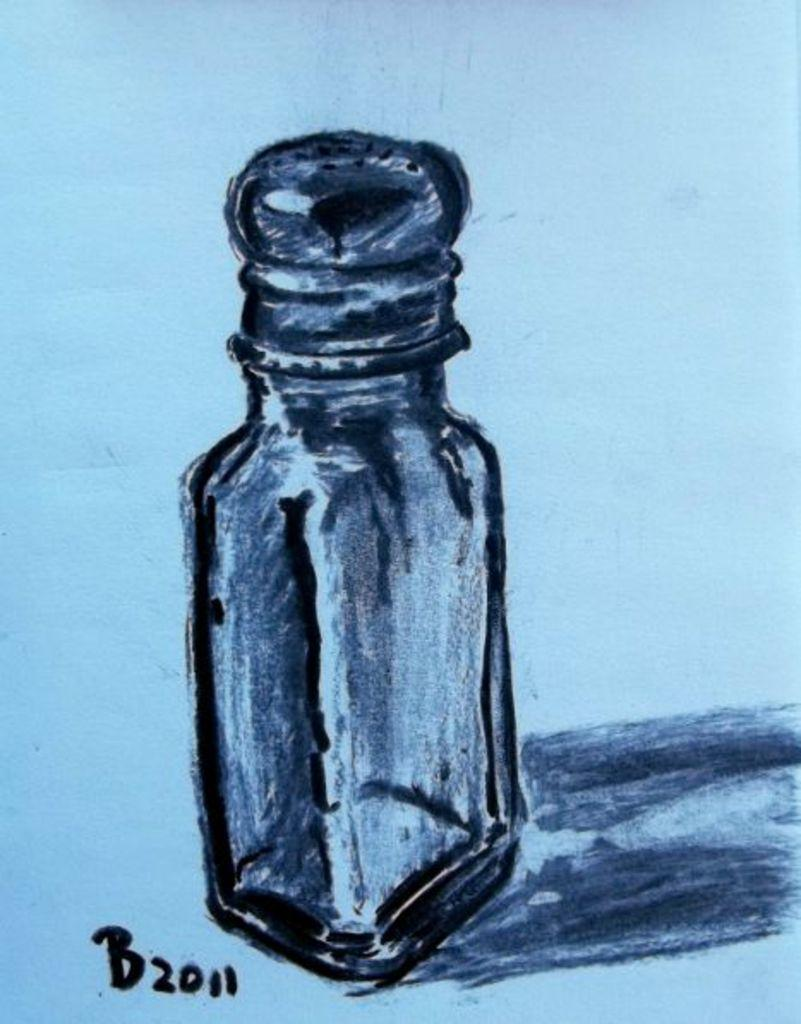<image>
Create a compact narrative representing the image presented. A sketch of a bottle with the number and letter B2011 at the bottom. 